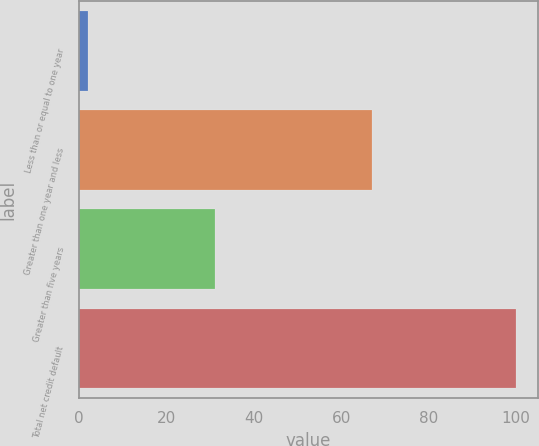Convert chart. <chart><loc_0><loc_0><loc_500><loc_500><bar_chart><fcel>Less than or equal to one year<fcel>Greater than one year and less<fcel>Greater than five years<fcel>Total net credit default<nl><fcel>2<fcel>67<fcel>31<fcel>100<nl></chart> 